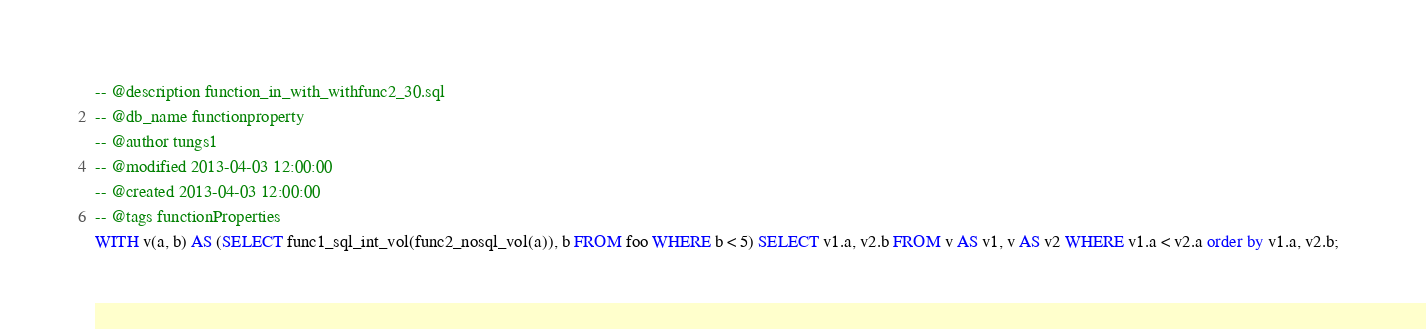<code> <loc_0><loc_0><loc_500><loc_500><_SQL_>-- @description function_in_with_withfunc2_30.sql
-- @db_name functionproperty
-- @author tungs1
-- @modified 2013-04-03 12:00:00
-- @created 2013-04-03 12:00:00
-- @tags functionProperties 
WITH v(a, b) AS (SELECT func1_sql_int_vol(func2_nosql_vol(a)), b FROM foo WHERE b < 5) SELECT v1.a, v2.b FROM v AS v1, v AS v2 WHERE v1.a < v2.a order by v1.a, v2.b;  
</code> 